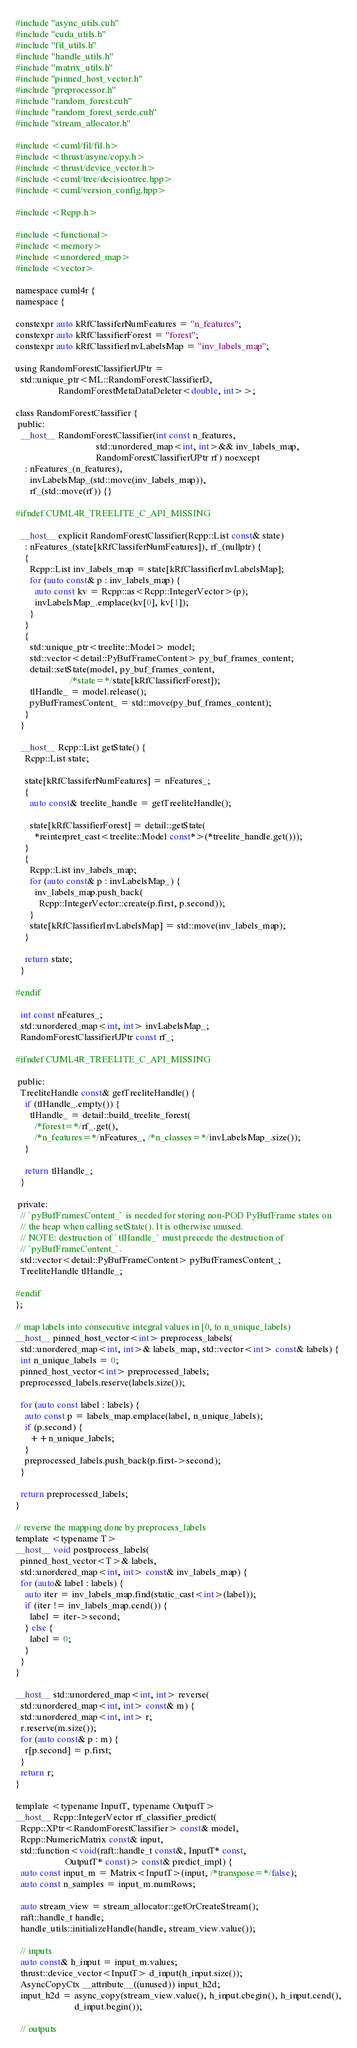<code> <loc_0><loc_0><loc_500><loc_500><_Cuda_>#include "async_utils.cuh"
#include "cuda_utils.h"
#include "fil_utils.h"
#include "handle_utils.h"
#include "matrix_utils.h"
#include "pinned_host_vector.h"
#include "preprocessor.h"
#include "random_forest.cuh"
#include "random_forest_serde.cuh"
#include "stream_allocator.h"

#include <cuml/fil/fil.h>
#include <thrust/async/copy.h>
#include <thrust/device_vector.h>
#include <cuml/tree/decisiontree.hpp>
#include <cuml/version_config.hpp>

#include <Rcpp.h>

#include <functional>
#include <memory>
#include <unordered_map>
#include <vector>

namespace cuml4r {
namespace {

constexpr auto kRfClassiferNumFeatures = "n_features";
constexpr auto kRfClassifierForest = "forest";
constexpr auto kRfClassifierInvLabelsMap = "inv_labels_map";

using RandomForestClassifierUPtr =
  std::unique_ptr<ML::RandomForestClassifierD,
                  RandomForestMetaDataDeleter<double, int>>;

class RandomForestClassifier {
 public:
  __host__ RandomForestClassifier(int const n_features,
                                  std::unordered_map<int, int>&& inv_labels_map,
                                  RandomForestClassifierUPtr rf) noexcept
    : nFeatures_(n_features),
      invLabelsMap_(std::move(inv_labels_map)),
      rf_(std::move(rf)) {}

#ifndef CUML4R_TREELITE_C_API_MISSING

  __host__ explicit RandomForestClassifier(Rcpp::List const& state)
    : nFeatures_(state[kRfClassiferNumFeatures]), rf_(nullptr) {
    {
      Rcpp::List inv_labels_map = state[kRfClassifierInvLabelsMap];
      for (auto const& p : inv_labels_map) {
        auto const kv = Rcpp::as<Rcpp::IntegerVector>(p);
        invLabelsMap_.emplace(kv[0], kv[1]);
      }
    }
    {
      std::unique_ptr<treelite::Model> model;
      std::vector<detail::PyBufFrameContent> py_buf_frames_content;
      detail::setState(model, py_buf_frames_content,
                       /*state=*/state[kRfClassifierForest]);
      tlHandle_ = model.release();
      pyBufFramesContent_ = std::move(py_buf_frames_content);
    }
  }

  __host__ Rcpp::List getState() {
    Rcpp::List state;

    state[kRfClassiferNumFeatures] = nFeatures_;
    {
      auto const& treelite_handle = getTreeliteHandle();

      state[kRfClassifierForest] = detail::getState(
        *reinterpret_cast<treelite::Model const*>(*treelite_handle.get()));
    }
    {
      Rcpp::List inv_labels_map;
      for (auto const& p : invLabelsMap_) {
        inv_labels_map.push_back(
          Rcpp::IntegerVector::create(p.first, p.second));
      }
      state[kRfClassifierInvLabelsMap] = std::move(inv_labels_map);
    }

    return state;
  }

#endif

  int const nFeatures_;
  std::unordered_map<int, int> invLabelsMap_;
  RandomForestClassifierUPtr const rf_;

#ifndef CUML4R_TREELITE_C_API_MISSING

 public:
  TreeliteHandle const& getTreeliteHandle() {
    if (tlHandle_.empty()) {
      tlHandle_ = detail::build_treelite_forest(
        /*forest=*/rf_.get(),
        /*n_features=*/nFeatures_, /*n_classes=*/invLabelsMap_.size());
    }

    return tlHandle_;
  }

 private:
  // `pyBufFramesContent_` is needed for storing non-POD PyBufFrame states on
  // the heap when calling setState(). It is otherwise unused.
  // NOTE: destruction of `tlHandle_` must precede the destruction of
  // `pyBufFrameContent_`.
  std::vector<detail::PyBufFrameContent> pyBufFramesContent_;
  TreeliteHandle tlHandle_;

#endif
};

// map labels into consecutive integral values in [0, to n_unique_labels)
__host__ pinned_host_vector<int> preprocess_labels(
  std::unordered_map<int, int>& labels_map, std::vector<int> const& labels) {
  int n_unique_labels = 0;
  pinned_host_vector<int> preprocessed_labels;
  preprocessed_labels.reserve(labels.size());

  for (auto const label : labels) {
    auto const p = labels_map.emplace(label, n_unique_labels);
    if (p.second) {
      ++n_unique_labels;
    }
    preprocessed_labels.push_back(p.first->second);
  }

  return preprocessed_labels;
}

// reverse the mapping done by preprocess_labels
template <typename T>
__host__ void postprocess_labels(
  pinned_host_vector<T>& labels,
  std::unordered_map<int, int> const& inv_labels_map) {
  for (auto& label : labels) {
    auto iter = inv_labels_map.find(static_cast<int>(label));
    if (iter != inv_labels_map.cend()) {
      label = iter->second;
    } else {
      label = 0;
    }
  }
}

__host__ std::unordered_map<int, int> reverse(
  std::unordered_map<int, int> const& m) {
  std::unordered_map<int, int> r;
  r.reserve(m.size());
  for (auto const& p : m) {
    r[p.second] = p.first;
  }
  return r;
}

template <typename InputT, typename OutputT>
__host__ Rcpp::IntegerVector rf_classifier_predict(
  Rcpp::XPtr<RandomForestClassifier> const& model,
  Rcpp::NumericMatrix const& input,
  std::function<void(raft::handle_t const&, InputT* const,
                     OutputT* const)> const& predict_impl) {
  auto const input_m = Matrix<InputT>(input, /*transpose=*/false);
  auto const n_samples = input_m.numRows;

  auto stream_view = stream_allocator::getOrCreateStream();
  raft::handle_t handle;
  handle_utils::initializeHandle(handle, stream_view.value());

  // inputs
  auto const& h_input = input_m.values;
  thrust::device_vector<InputT> d_input(h_input.size());
  AsyncCopyCtx __attribute__((unused)) input_h2d;
  input_h2d = async_copy(stream_view.value(), h_input.cbegin(), h_input.cend(),
                         d_input.begin());

  // outputs</code> 